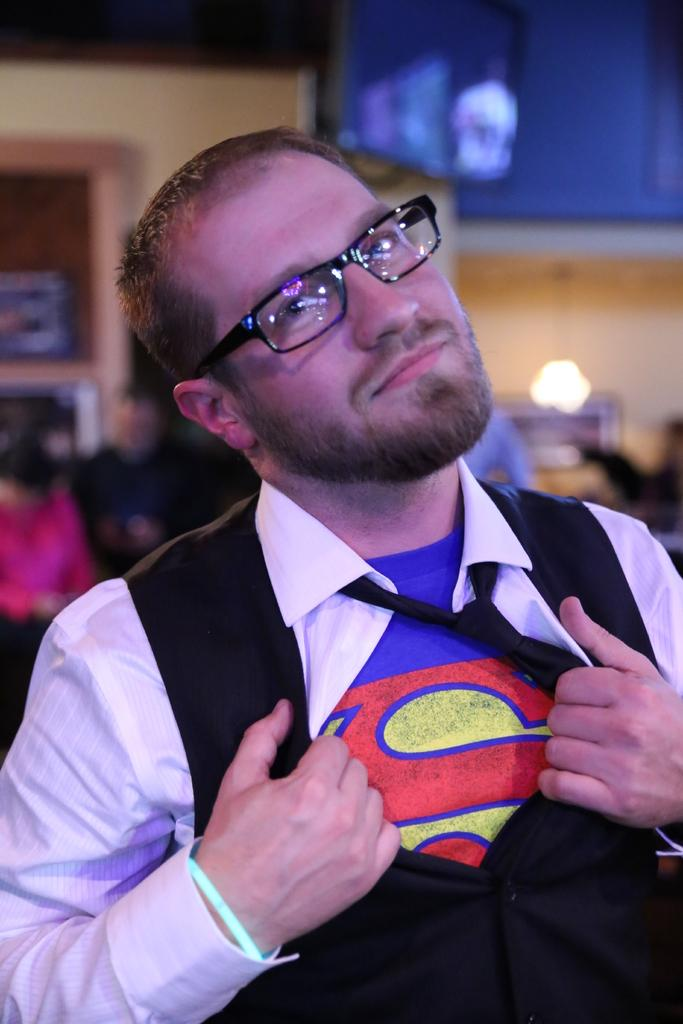What is the main subject of the image? There is a person in the image. What is the person doing in the image? The person is watching something and holding clothes. Can you describe the background of the image? The background of the image has a blurred view. Are there any other people visible in the image? Yes, there are other people visible in the image. What type of mass is being used to hold the clothes in the image? There is no mention of mass in the image; the person is simply holding the clothes. Can you see any snails in the image? There are no snails present in the image. 